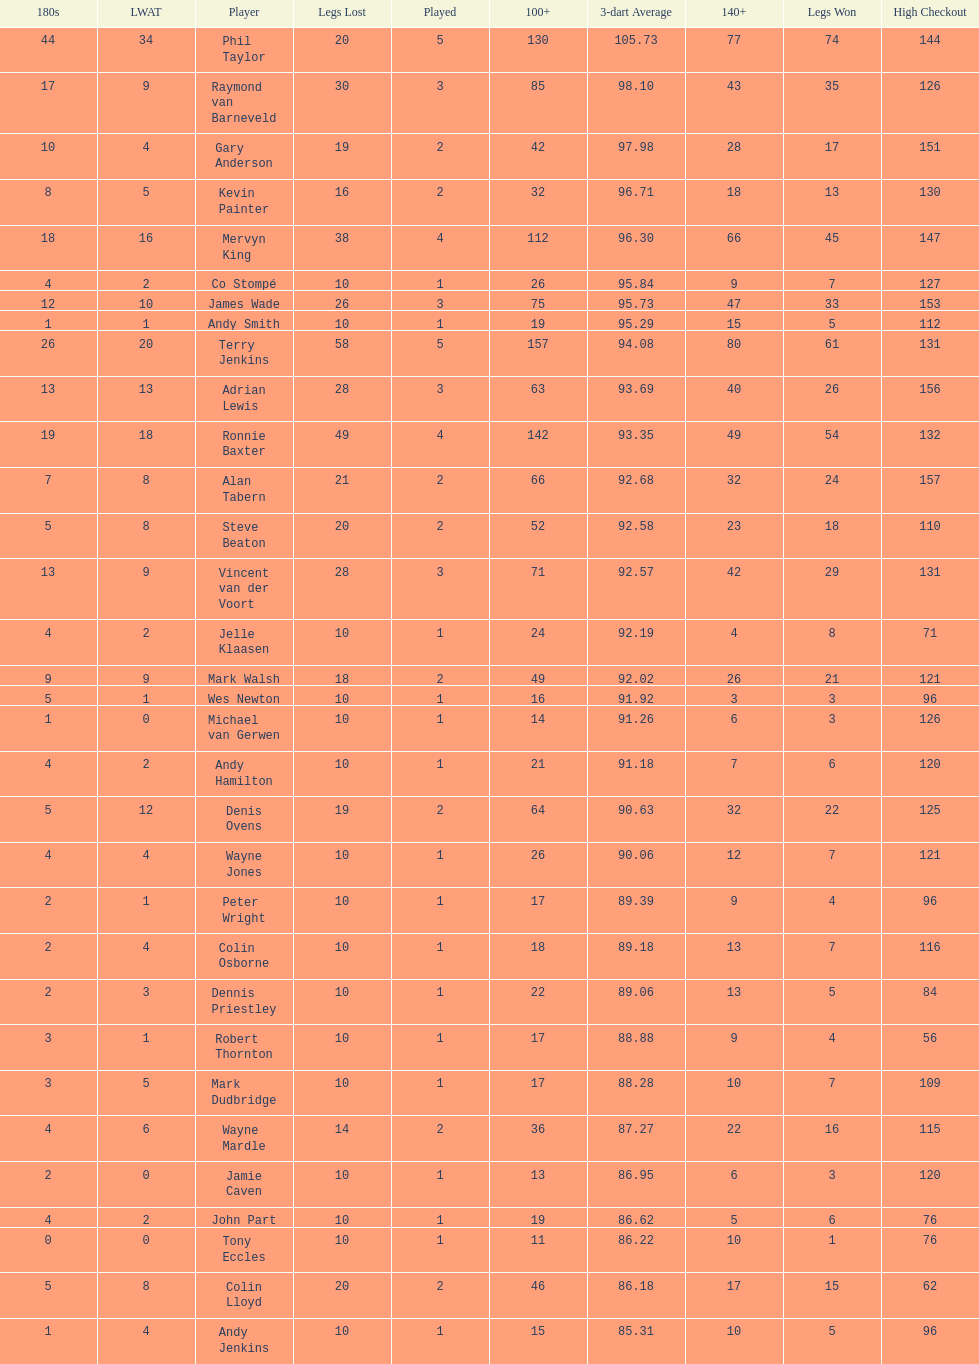What is the name of the next player after mark walsh? Wes Newton. 